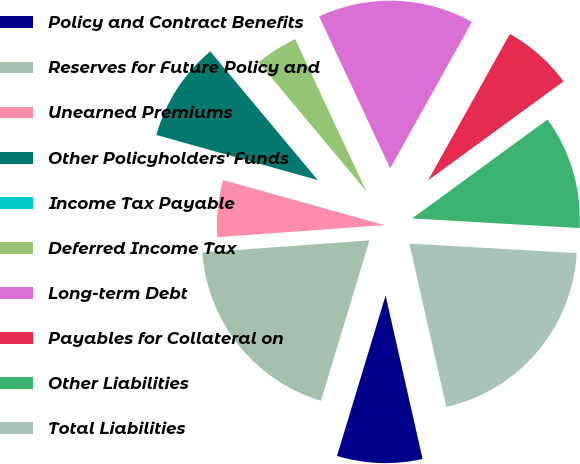Convert chart to OTSL. <chart><loc_0><loc_0><loc_500><loc_500><pie_chart><fcel>Policy and Contract Benefits<fcel>Reserves for Future Policy and<fcel>Unearned Premiums<fcel>Other Policyholders' Funds<fcel>Income Tax Payable<fcel>Deferred Income Tax<fcel>Long-term Debt<fcel>Payables for Collateral on<fcel>Other Liabilities<fcel>Total Liabilities<nl><fcel>8.22%<fcel>19.17%<fcel>5.48%<fcel>9.59%<fcel>0.0%<fcel>4.11%<fcel>15.07%<fcel>6.85%<fcel>10.96%<fcel>20.54%<nl></chart> 